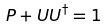Convert formula to latex. <formula><loc_0><loc_0><loc_500><loc_500>P + U U ^ { \dagger } = 1</formula> 